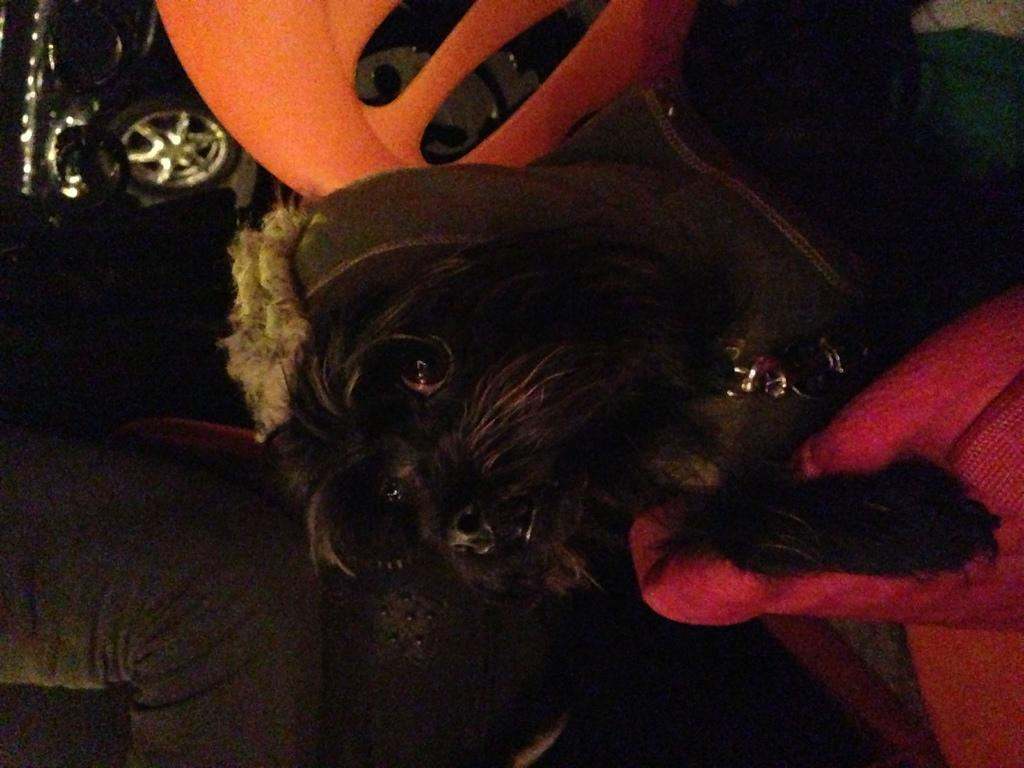What type of animal can be seen in the image? There is a dog in the image. What else is present in the image besides the dog? There is a vehicle and some persons in the image. Can you describe the vehicle in the image? Unfortunately, the facts provided do not specify the type of vehicle in the image. What are the unspecified objects in the image? The facts provided do not specify the nature of the unspecified objects in the image. How many cows are visible in the image? There are no cows present in the image. What type of observation can be made about the back of the persons in the image? The facts provided do not offer any information about the persons' backs, so it is impossible to make such an observation. 